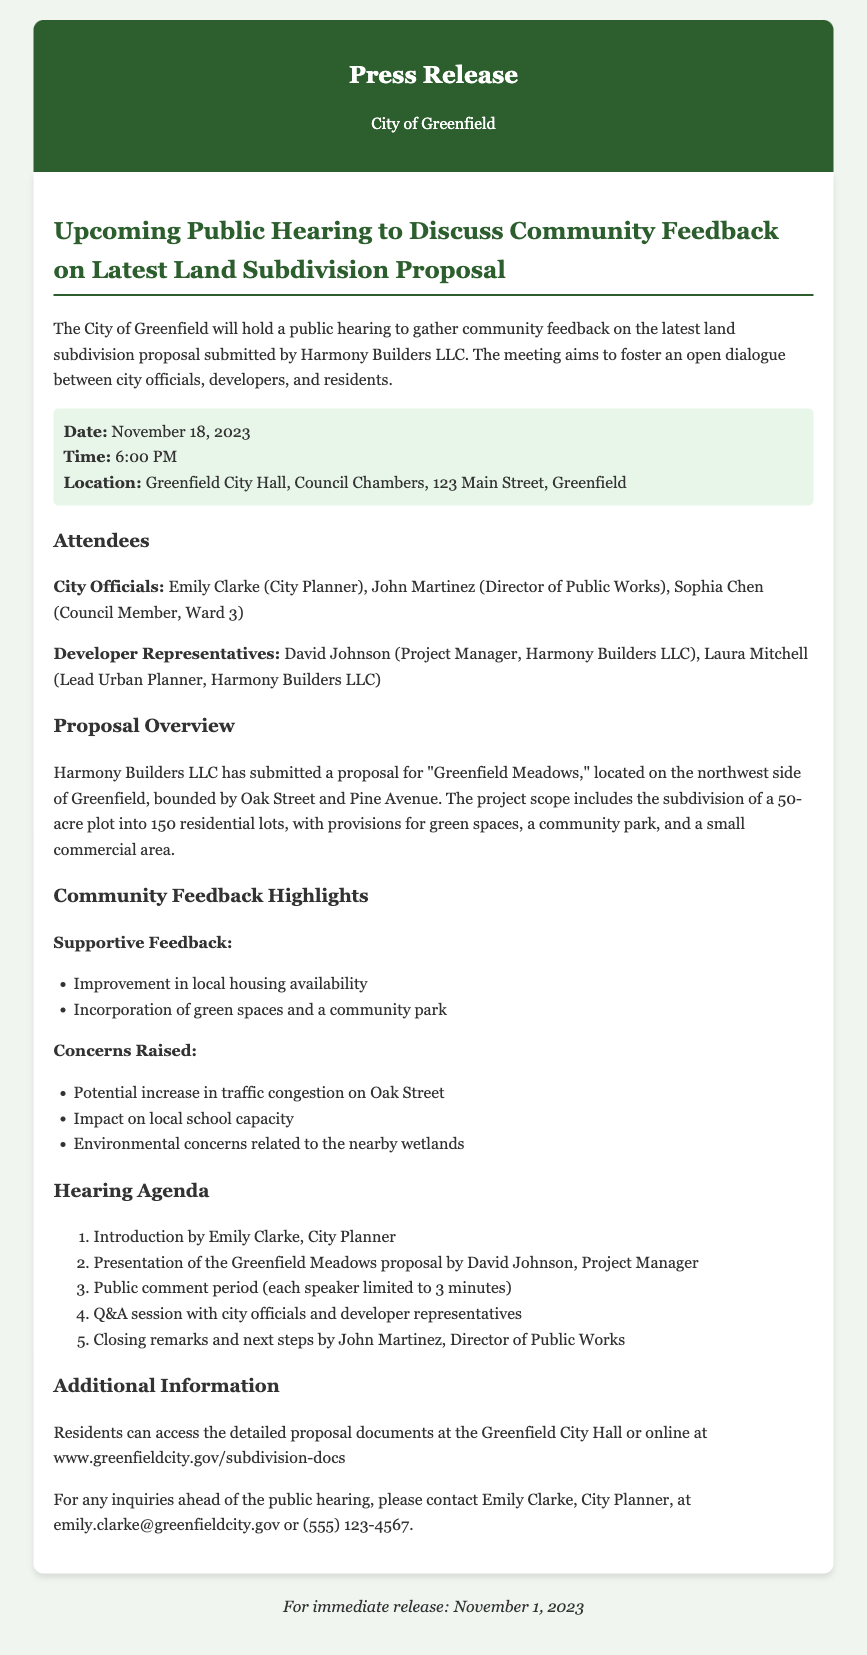What is the date of the public hearing? The date of the public hearing is explicitly stated in the document as November 18, 2023.
Answer: November 18, 2023 Who submitted the land subdivision proposal? The document specifies that the proposal was submitted by Harmony Builders LLC.
Answer: Harmony Builders LLC How many residential lots are proposed in the Greenfield Meadows project? The document mentions the subdivision includes 150 residential lots.
Answer: 150 What are some supportive feedback points mentioned by the community? The document lists points of supportive feedback, including improvement in local housing availability and incorporation of green spaces and a community park.
Answer: Improvement in local housing availability What are the potential concerns raised by the community? The document includes concerns, such as potential increase in traffic congestion on Oak Street, impact on local school capacity, and environmental concerns related to the nearby wetlands.
Answer: Potential increase in traffic congestion on Oak Street Who is the City Planner mentioned in the hearing agenda? The document names Emily Clarke as the City Planner who will introduce the hearing.
Answer: Emily Clarke What is one of the goals of the public hearing? The document states that the hearing aims to foster an open dialogue between city officials, developers, and residents.
Answer: Foster an open dialogue What is the location of the public hearing? The document provides the location as Greenfield City Hall, Council Chambers, 123 Main Street, Greenfield.
Answer: Greenfield City Hall, Council Chambers, 123 Main Street, Greenfield What is the contact email for inquiries before the hearing? The document lists the contact email for inquiries as emily.clarke@greenfieldcity.gov.
Answer: emily.clarke@greenfieldcity.gov 